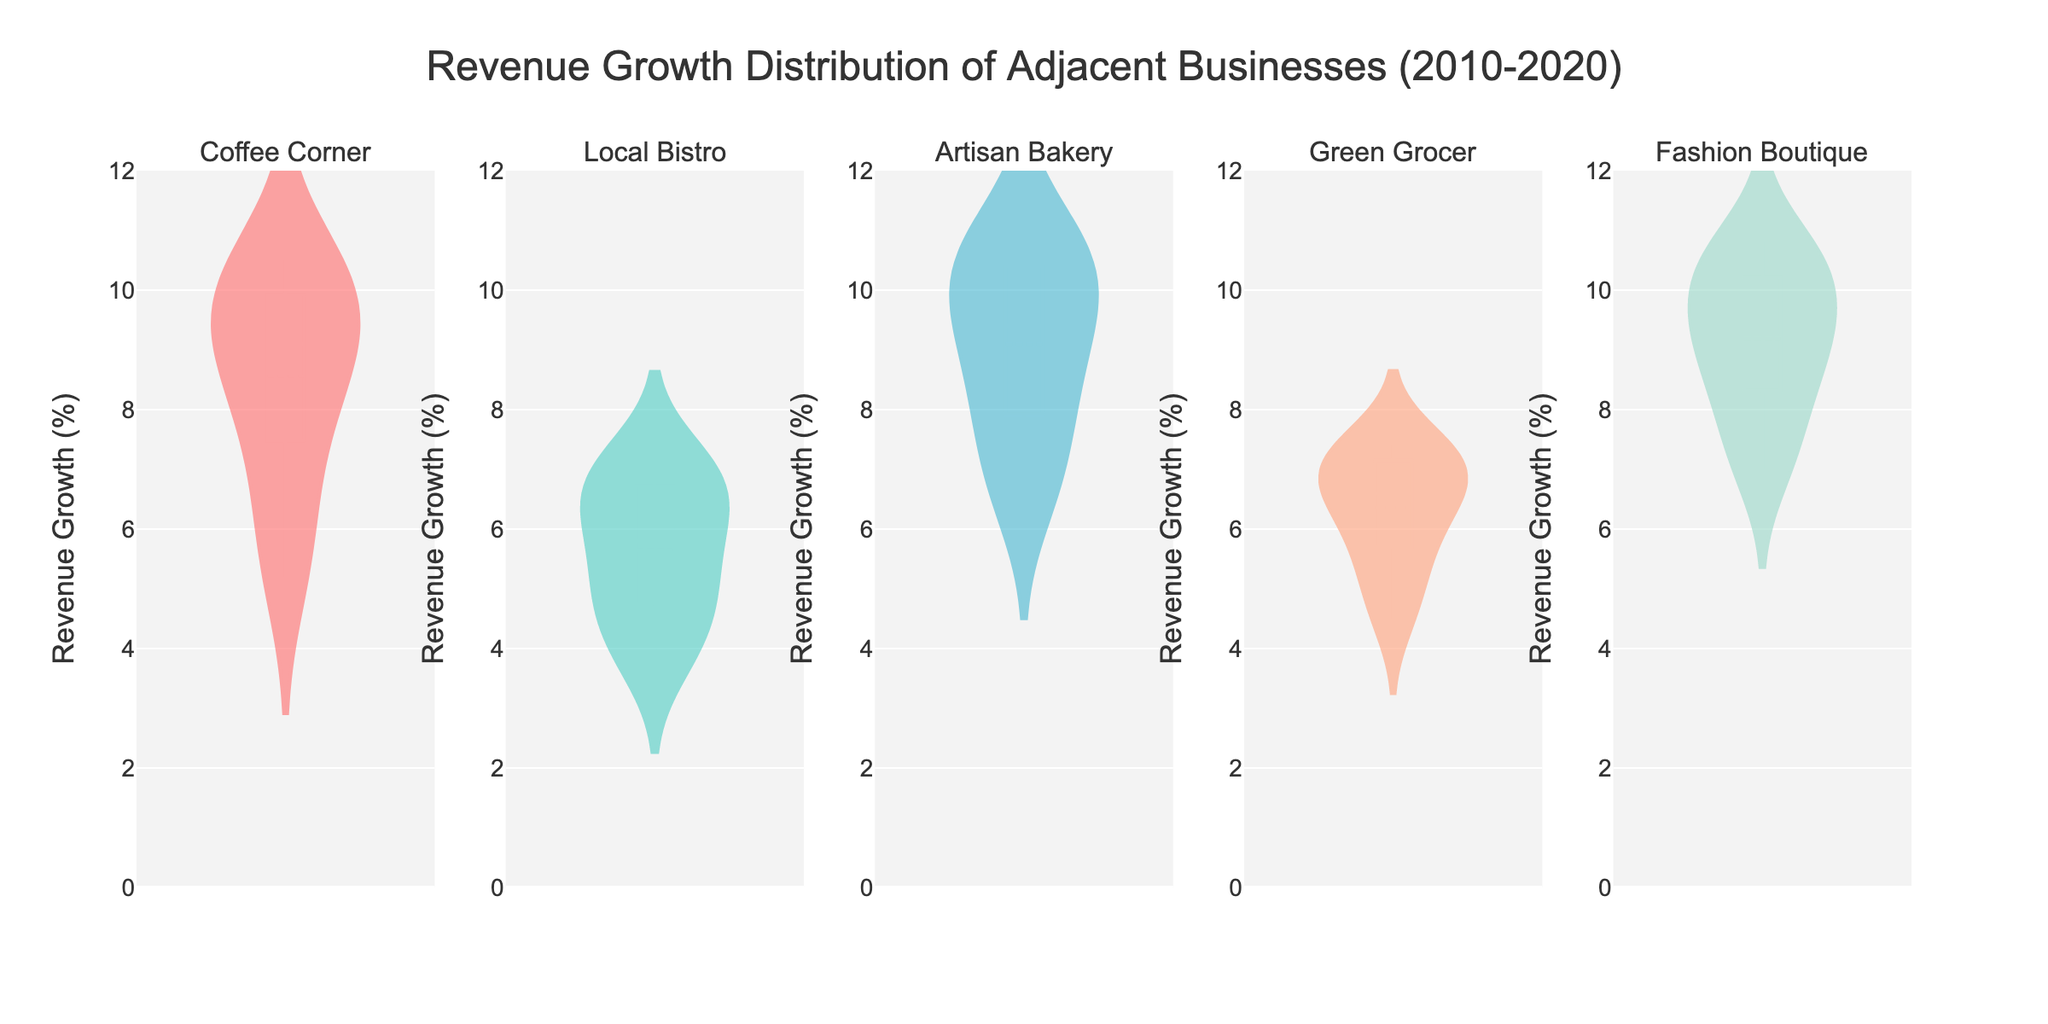How many business subplots are there? There are five business subplots: "Coffee Corner", "Local Bistro", "Artisan Bakery", "Green Grocer", and "Fashion Boutique" as indicated by the titles of the subplots.
Answer: 5 What is the title of the figure? The title is displayed at the top center of the figure. It reads "Revenue Growth Distribution of Adjacent Businesses (2010-2020)."
Answer: Revenue Growth Distribution of Adjacent Businesses (2010-2020) What is the range of the y-axis? The y-axis range is shown from 0 to 12, as indicated by the axis labels and ticks.
Answer: 0 to 12 Which business has the highest peak in revenue growth distribution? The highest peak can be observed in the plot with the highest density or the tallest violin shape, which is typically "Fashion Boutique" as its revenue growth shows the highest values close to 10-10.8%.
Answer: Fashion Boutique Are the mean values of the distributions visible? Yes, the mean values are visible as horizontal lines within each violin plot.
Answer: Yes Which business shows revenue growth that always falls within a narrower range? The business with the narrowest violin shape, indicating less variability, is "Local Bistro" whose revenue growth values are tightly grouped around the median compared to the other businesses.
Answer: Local Bistro What is the general trend for revenue growth in "Coffee Corner" between 2010 and 2020? The violin plot for "Coffee Corner" shows an increasing trend, as the distribution starts lower around 5.2% in 2010 and increases to around 10.5% by 2020.
Answer: Increasing trend Which business has the lowest overall revenue growth values? "Local Bistro" has the lowest set of revenue growth values, which are centered around 3.8% to 7.1% over the years.
Answer: Local Bistro How does the revenue growth of "Green Grocer" compare to "Artisan Bakery"? By comparing the violin plots, "Green Grocer" shows a revenue growth range between about 4.5% and 7.4%, while "Artisan Bakery" has a higher revenue growth range between approximately 6.5% and 10.9%.
Answer: "Artisan Bakery" has higher growth Are revenue growth distributions for all businesses symmetrical? The shapes of the violins show that while some distributions might be symmetrical, others, such as "Fashion Boutique" and "Artisan Bakery", are slightly skewed to the right.
Answer: No 